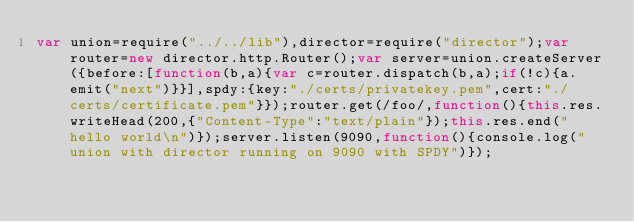<code> <loc_0><loc_0><loc_500><loc_500><_JavaScript_>var union=require("../../lib"),director=require("director");var router=new director.http.Router();var server=union.createServer({before:[function(b,a){var c=router.dispatch(b,a);if(!c){a.emit("next")}}],spdy:{key:"./certs/privatekey.pem",cert:"./certs/certificate.pem"}});router.get(/foo/,function(){this.res.writeHead(200,{"Content-Type":"text/plain"});this.res.end("hello world\n")});server.listen(9090,function(){console.log("union with director running on 9090 with SPDY")});</code> 